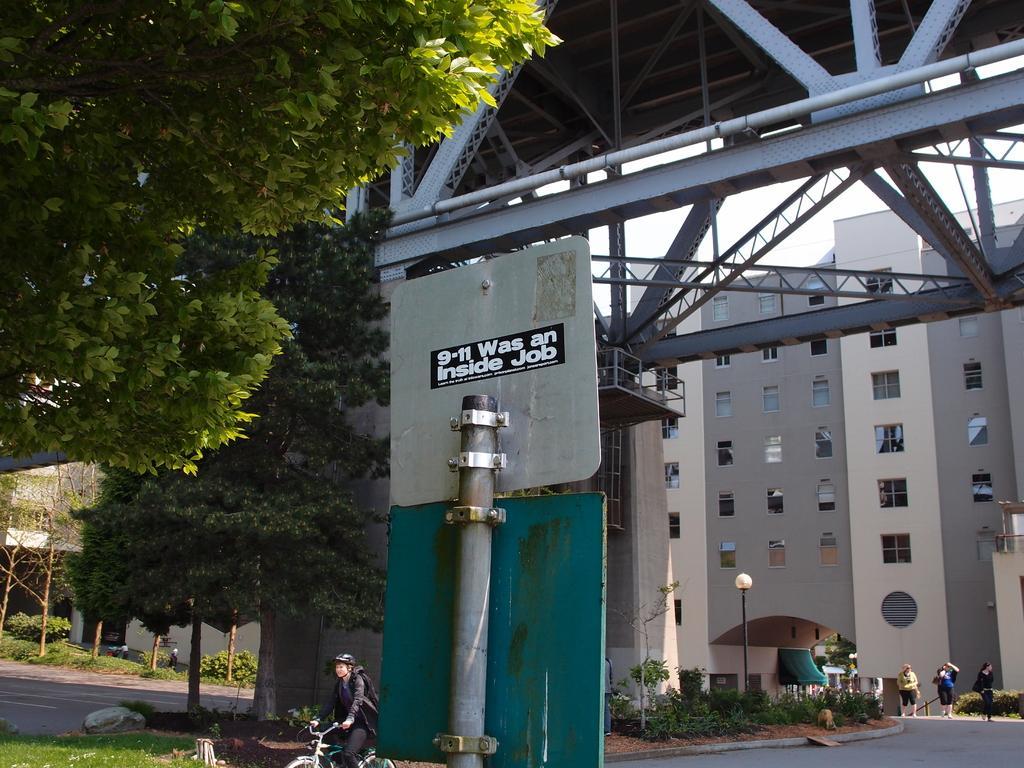Please provide a concise description of this image. In this picture there are boards on the pole and there is a person riding bicycle on the road. On the right side of the image there are group of people walking. At the back there are buildings, trees and poles. At the top there is sky. At the bottom there is a road and there is grass. 